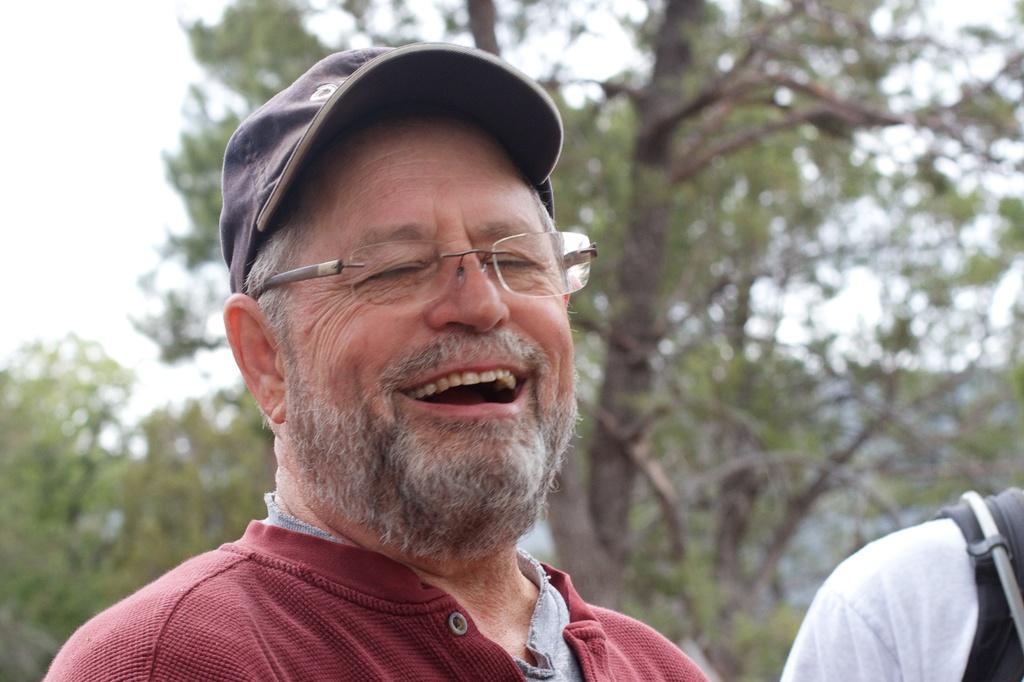Could you give a brief overview of what you see in this image? This image consists of a man wearing a red T-shirt is laughing. On the right, there is another person. In the background, there are trees. At the top, there is sky. 